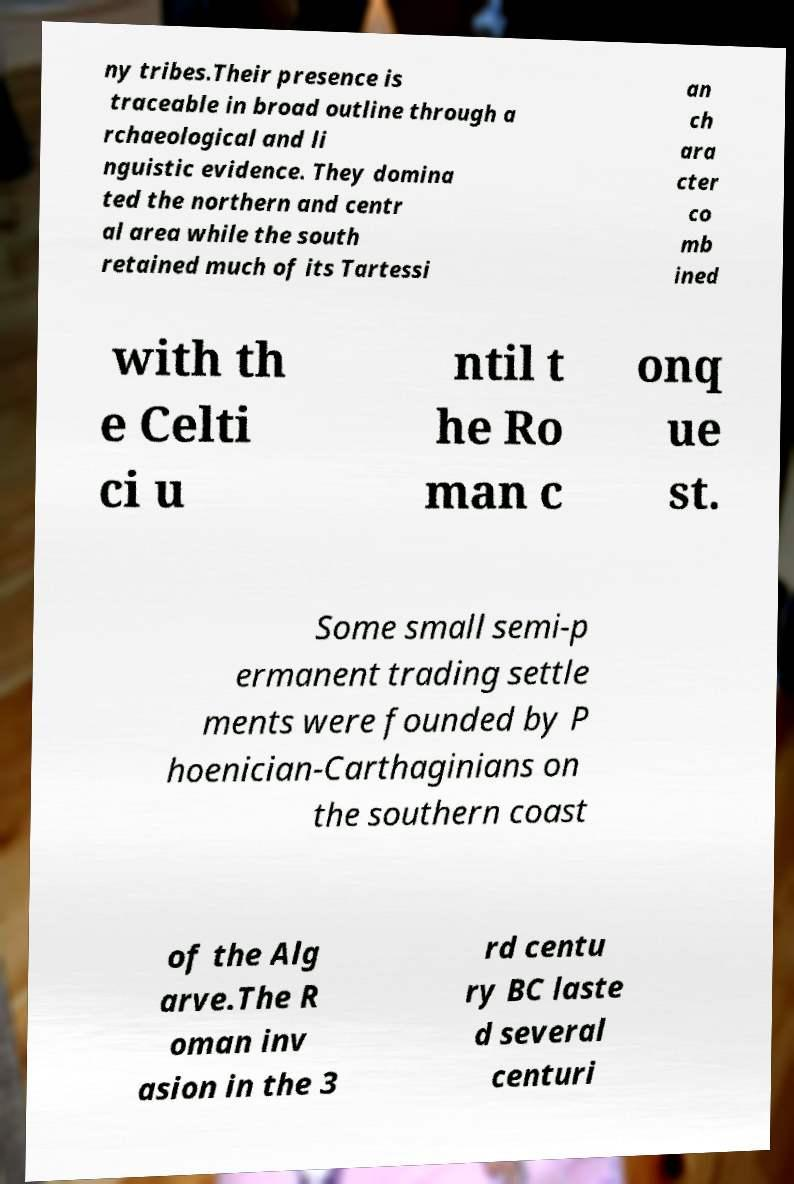Can you read and provide the text displayed in the image?This photo seems to have some interesting text. Can you extract and type it out for me? ny tribes.Their presence is traceable in broad outline through a rchaeological and li nguistic evidence. They domina ted the northern and centr al area while the south retained much of its Tartessi an ch ara cter co mb ined with th e Celti ci u ntil t he Ro man c onq ue st. Some small semi-p ermanent trading settle ments were founded by P hoenician-Carthaginians on the southern coast of the Alg arve.The R oman inv asion in the 3 rd centu ry BC laste d several centuri 